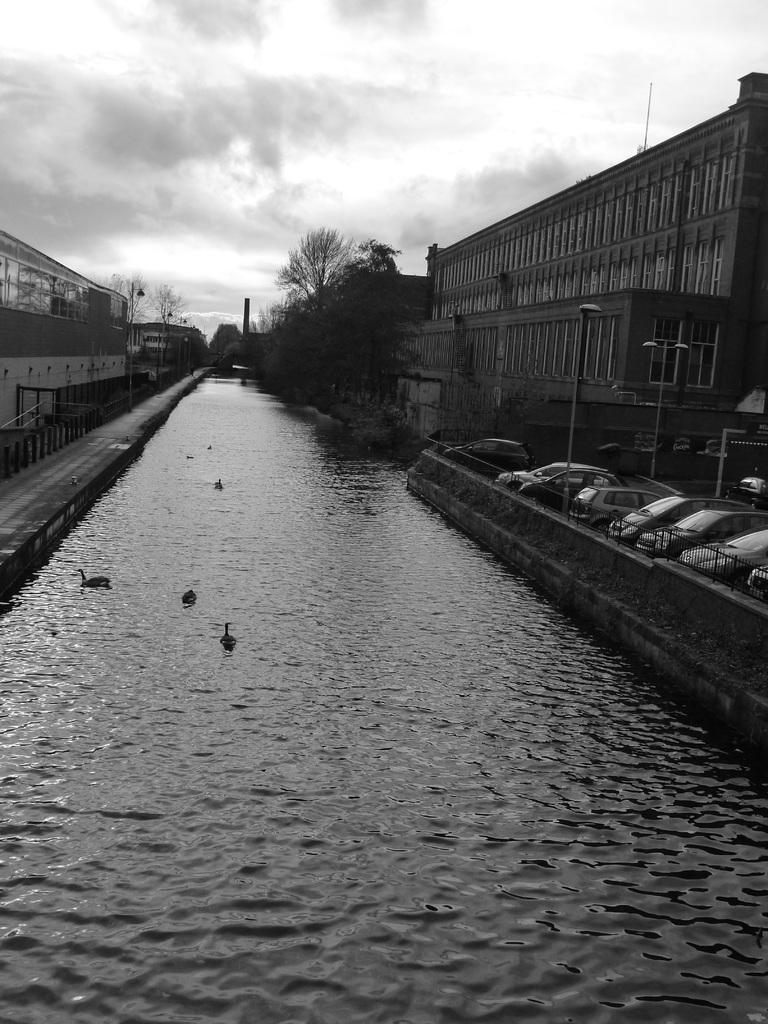Can you describe this image briefly? In this image I can see in the middle it looks like a canal, there are birds in it. On the right side there are cars, there are trees and buildings on either side of this image. At the top it is the cloudy sky, this image is in black and white color. 